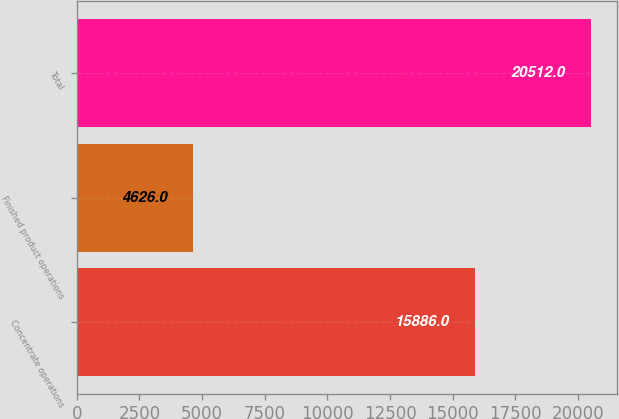<chart> <loc_0><loc_0><loc_500><loc_500><bar_chart><fcel>Concentrate operations<fcel>Finished product operations<fcel>Total<nl><fcel>15886<fcel>4626<fcel>20512<nl></chart> 